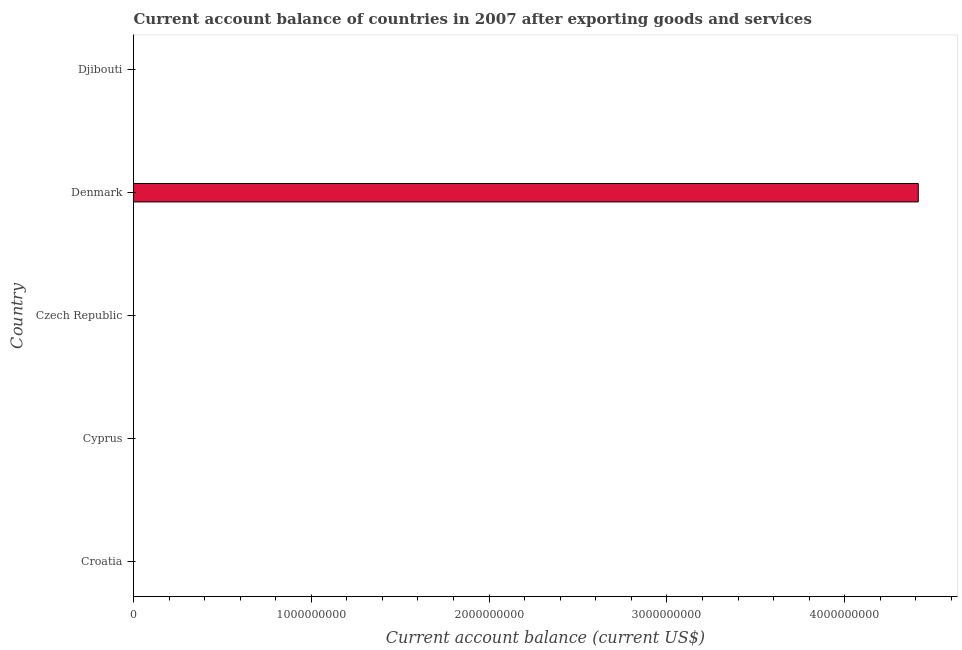Does the graph contain any zero values?
Give a very brief answer. Yes. Does the graph contain grids?
Keep it short and to the point. No. What is the title of the graph?
Make the answer very short. Current account balance of countries in 2007 after exporting goods and services. What is the label or title of the X-axis?
Offer a terse response. Current account balance (current US$). Across all countries, what is the maximum current account balance?
Provide a succinct answer. 4.41e+09. Across all countries, what is the minimum current account balance?
Your answer should be compact. 0. In which country was the current account balance maximum?
Give a very brief answer. Denmark. What is the sum of the current account balance?
Keep it short and to the point. 4.41e+09. What is the average current account balance per country?
Offer a terse response. 8.83e+08. In how many countries, is the current account balance greater than 3600000000 US$?
Provide a succinct answer. 1. What is the difference between the highest and the lowest current account balance?
Ensure brevity in your answer.  4.41e+09. In how many countries, is the current account balance greater than the average current account balance taken over all countries?
Provide a succinct answer. 1. How many bars are there?
Offer a very short reply. 1. How many countries are there in the graph?
Make the answer very short. 5. What is the difference between two consecutive major ticks on the X-axis?
Keep it short and to the point. 1.00e+09. Are the values on the major ticks of X-axis written in scientific E-notation?
Provide a succinct answer. No. What is the Current account balance (current US$) in Croatia?
Offer a terse response. 0. What is the Current account balance (current US$) in Czech Republic?
Your answer should be compact. 0. What is the Current account balance (current US$) of Denmark?
Provide a short and direct response. 4.41e+09. 